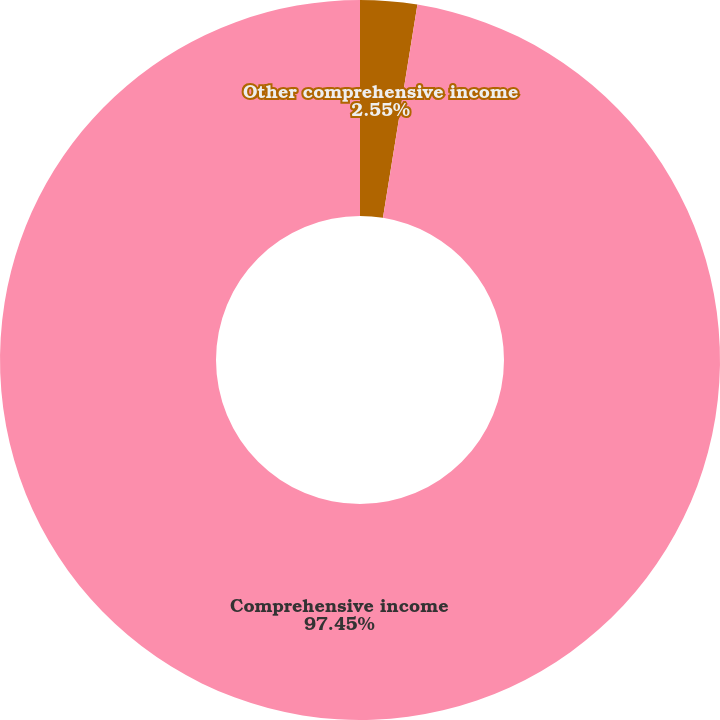Convert chart to OTSL. <chart><loc_0><loc_0><loc_500><loc_500><pie_chart><fcel>Other comprehensive income<fcel>Comprehensive income<nl><fcel>2.55%<fcel>97.45%<nl></chart> 